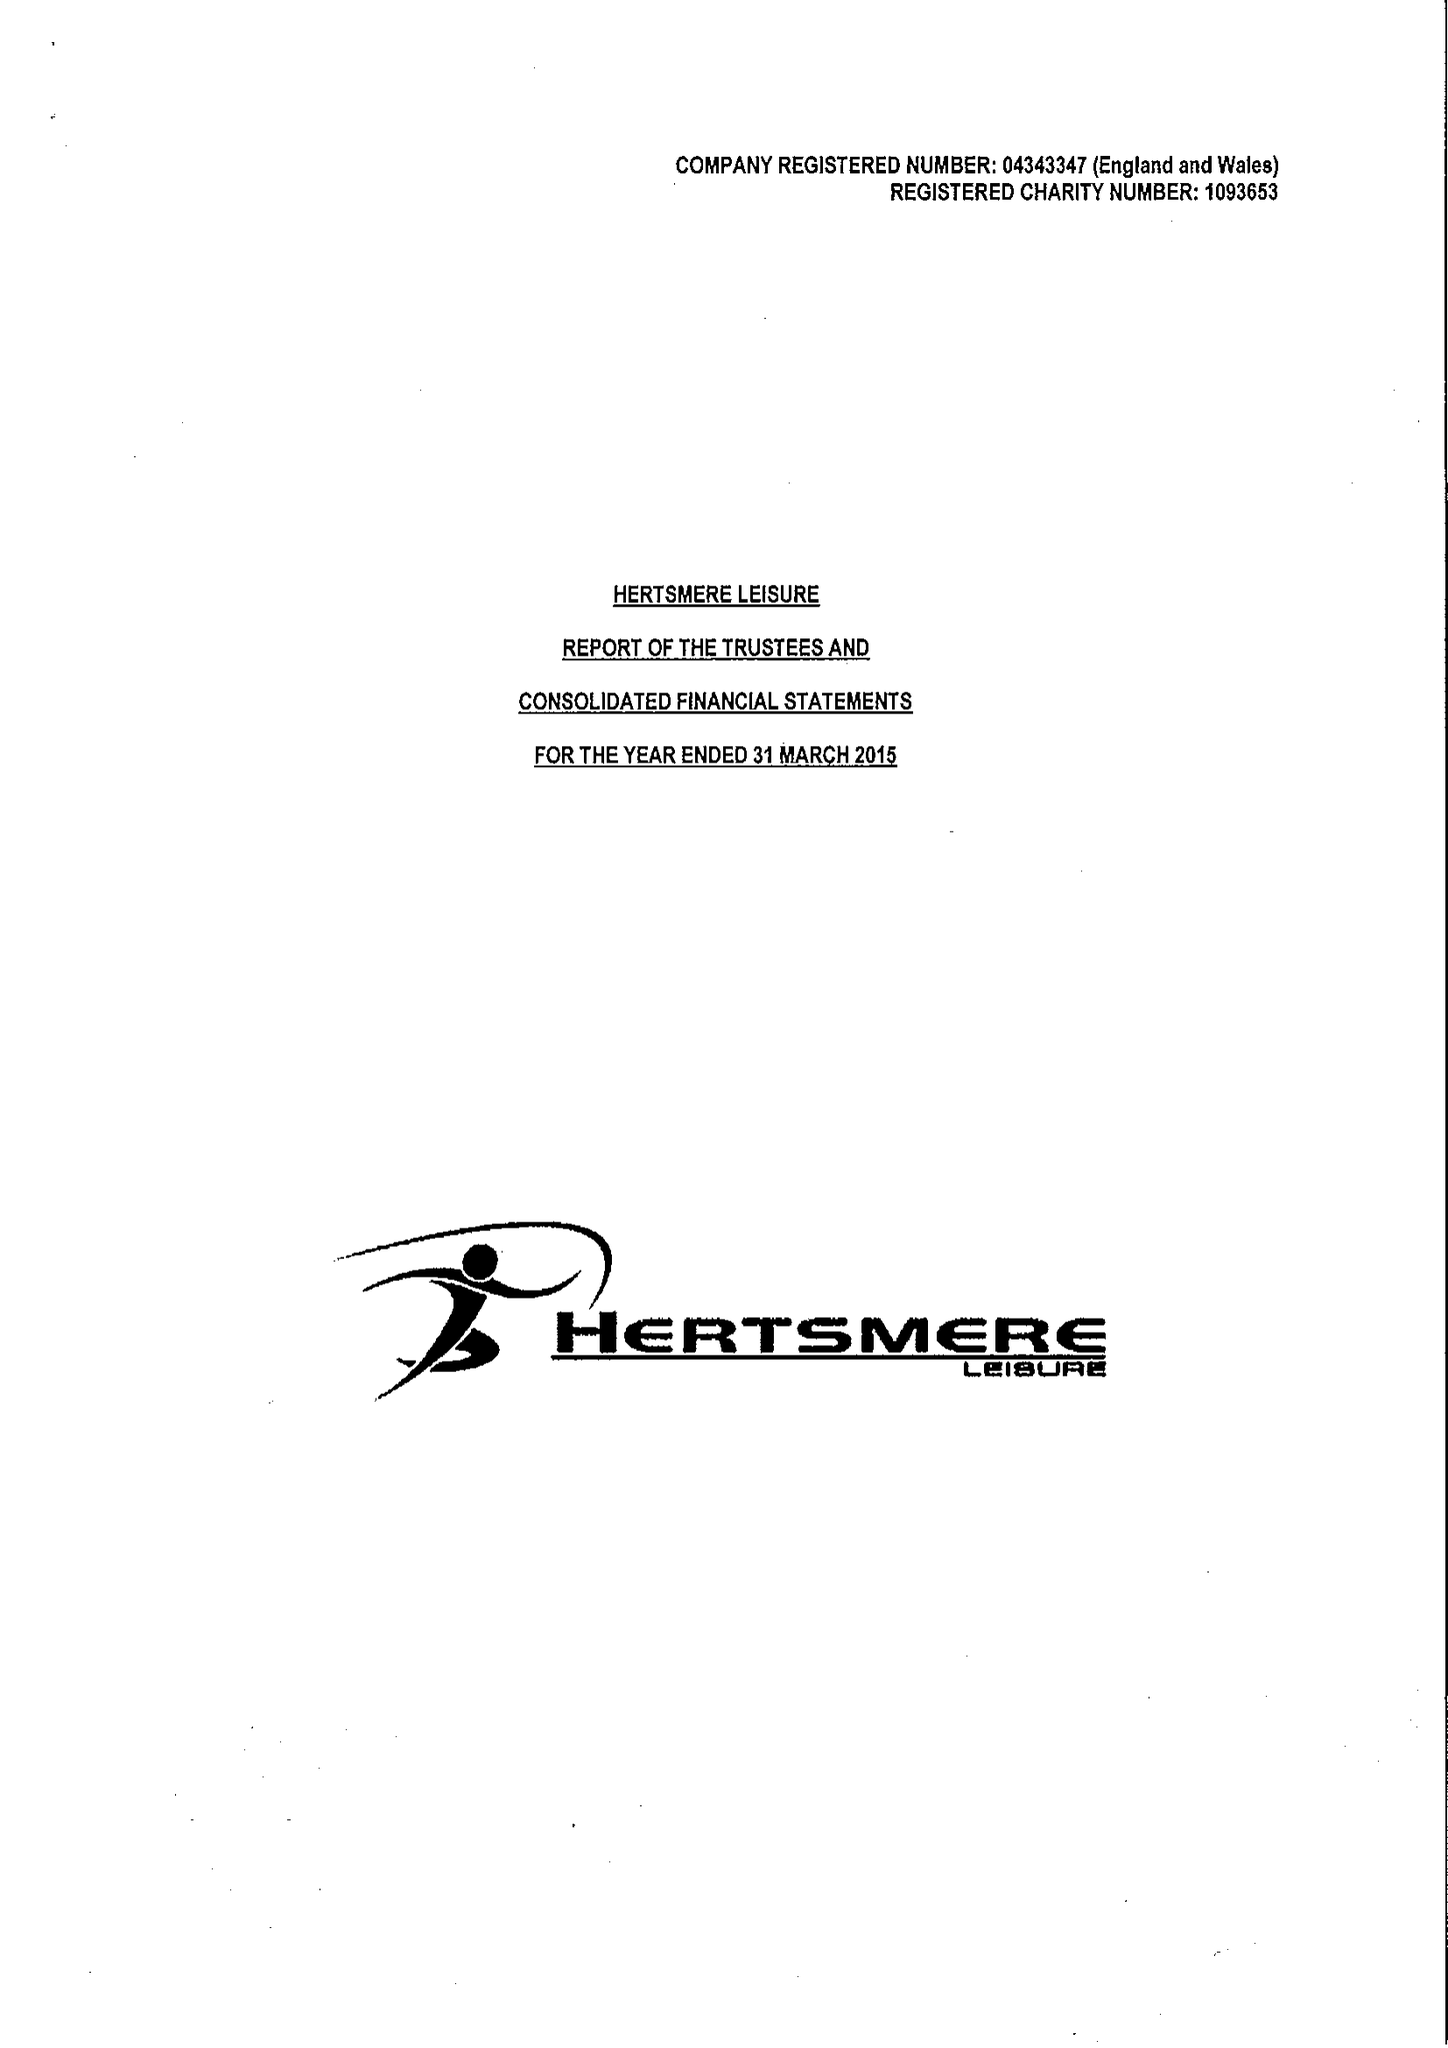What is the value for the spending_annually_in_british_pounds?
Answer the question using a single word or phrase. 18479706.00 